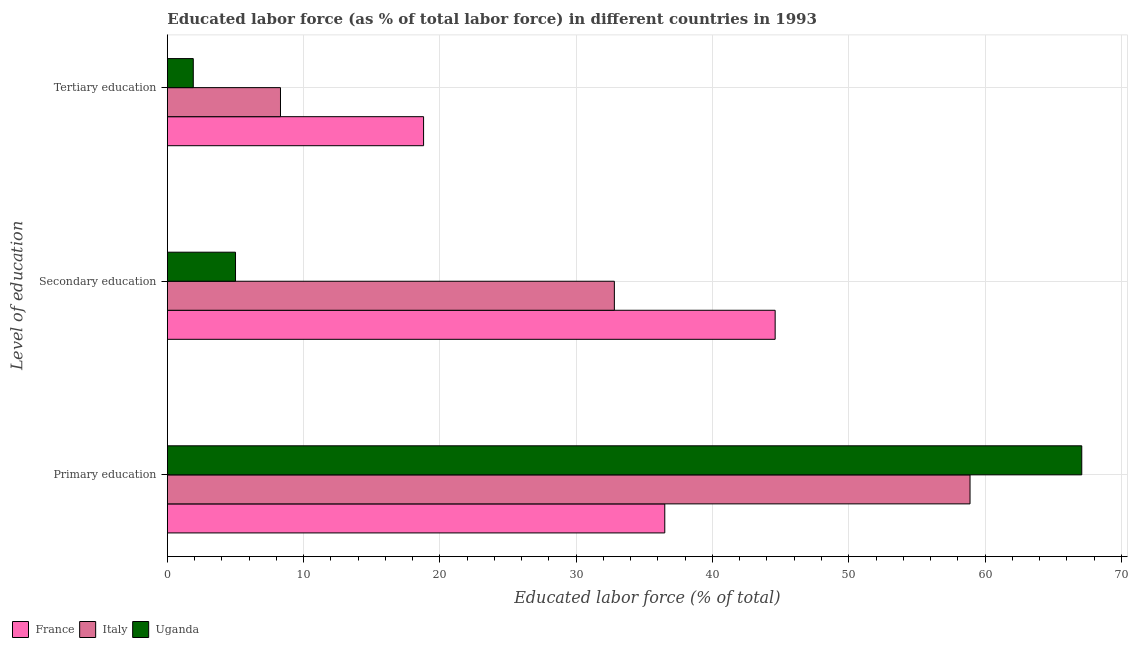How many different coloured bars are there?
Your answer should be very brief. 3. What is the label of the 1st group of bars from the top?
Your response must be concise. Tertiary education. What is the percentage of labor force who received secondary education in France?
Ensure brevity in your answer.  44.6. Across all countries, what is the maximum percentage of labor force who received secondary education?
Your response must be concise. 44.6. Across all countries, what is the minimum percentage of labor force who received primary education?
Your response must be concise. 36.5. In which country was the percentage of labor force who received secondary education maximum?
Make the answer very short. France. In which country was the percentage of labor force who received secondary education minimum?
Give a very brief answer. Uganda. What is the total percentage of labor force who received primary education in the graph?
Offer a terse response. 162.5. What is the difference between the percentage of labor force who received secondary education in Italy and that in Uganda?
Your answer should be compact. 27.8. What is the difference between the percentage of labor force who received secondary education in Italy and the percentage of labor force who received tertiary education in Uganda?
Offer a very short reply. 30.9. What is the average percentage of labor force who received secondary education per country?
Make the answer very short. 27.47. What is the difference between the percentage of labor force who received primary education and percentage of labor force who received secondary education in Italy?
Provide a short and direct response. 26.1. In how many countries, is the percentage of labor force who received secondary education greater than 26 %?
Offer a terse response. 2. What is the ratio of the percentage of labor force who received secondary education in France to that in Uganda?
Provide a succinct answer. 8.92. Is the difference between the percentage of labor force who received tertiary education in Uganda and France greater than the difference between the percentage of labor force who received primary education in Uganda and France?
Provide a short and direct response. No. What is the difference between the highest and the second highest percentage of labor force who received secondary education?
Make the answer very short. 11.8. What is the difference between the highest and the lowest percentage of labor force who received secondary education?
Your answer should be very brief. 39.6. In how many countries, is the percentage of labor force who received secondary education greater than the average percentage of labor force who received secondary education taken over all countries?
Provide a succinct answer. 2. Is the sum of the percentage of labor force who received tertiary education in Uganda and Italy greater than the maximum percentage of labor force who received primary education across all countries?
Make the answer very short. No. What does the 1st bar from the top in Primary education represents?
Ensure brevity in your answer.  Uganda. What does the 3rd bar from the bottom in Secondary education represents?
Offer a very short reply. Uganda. Are all the bars in the graph horizontal?
Give a very brief answer. Yes. How many countries are there in the graph?
Your response must be concise. 3. Are the values on the major ticks of X-axis written in scientific E-notation?
Offer a very short reply. No. What is the title of the graph?
Your response must be concise. Educated labor force (as % of total labor force) in different countries in 1993. What is the label or title of the X-axis?
Provide a succinct answer. Educated labor force (% of total). What is the label or title of the Y-axis?
Your answer should be compact. Level of education. What is the Educated labor force (% of total) in France in Primary education?
Offer a terse response. 36.5. What is the Educated labor force (% of total) of Italy in Primary education?
Provide a succinct answer. 58.9. What is the Educated labor force (% of total) in Uganda in Primary education?
Keep it short and to the point. 67.1. What is the Educated labor force (% of total) in France in Secondary education?
Your answer should be very brief. 44.6. What is the Educated labor force (% of total) of Italy in Secondary education?
Your response must be concise. 32.8. What is the Educated labor force (% of total) of France in Tertiary education?
Your answer should be very brief. 18.8. What is the Educated labor force (% of total) of Italy in Tertiary education?
Make the answer very short. 8.3. What is the Educated labor force (% of total) in Uganda in Tertiary education?
Your answer should be very brief. 1.9. Across all Level of education, what is the maximum Educated labor force (% of total) of France?
Offer a very short reply. 44.6. Across all Level of education, what is the maximum Educated labor force (% of total) in Italy?
Your answer should be very brief. 58.9. Across all Level of education, what is the maximum Educated labor force (% of total) of Uganda?
Offer a very short reply. 67.1. Across all Level of education, what is the minimum Educated labor force (% of total) of France?
Give a very brief answer. 18.8. Across all Level of education, what is the minimum Educated labor force (% of total) of Italy?
Provide a succinct answer. 8.3. Across all Level of education, what is the minimum Educated labor force (% of total) of Uganda?
Offer a very short reply. 1.9. What is the total Educated labor force (% of total) of France in the graph?
Ensure brevity in your answer.  99.9. What is the total Educated labor force (% of total) in Italy in the graph?
Make the answer very short. 100. What is the difference between the Educated labor force (% of total) of Italy in Primary education and that in Secondary education?
Provide a short and direct response. 26.1. What is the difference between the Educated labor force (% of total) of Uganda in Primary education and that in Secondary education?
Your response must be concise. 62.1. What is the difference between the Educated labor force (% of total) of France in Primary education and that in Tertiary education?
Make the answer very short. 17.7. What is the difference between the Educated labor force (% of total) in Italy in Primary education and that in Tertiary education?
Give a very brief answer. 50.6. What is the difference between the Educated labor force (% of total) of Uganda in Primary education and that in Tertiary education?
Keep it short and to the point. 65.2. What is the difference between the Educated labor force (% of total) of France in Secondary education and that in Tertiary education?
Make the answer very short. 25.8. What is the difference between the Educated labor force (% of total) of Uganda in Secondary education and that in Tertiary education?
Make the answer very short. 3.1. What is the difference between the Educated labor force (% of total) in France in Primary education and the Educated labor force (% of total) in Italy in Secondary education?
Offer a very short reply. 3.7. What is the difference between the Educated labor force (% of total) in France in Primary education and the Educated labor force (% of total) in Uganda in Secondary education?
Make the answer very short. 31.5. What is the difference between the Educated labor force (% of total) in Italy in Primary education and the Educated labor force (% of total) in Uganda in Secondary education?
Provide a short and direct response. 53.9. What is the difference between the Educated labor force (% of total) of France in Primary education and the Educated labor force (% of total) of Italy in Tertiary education?
Your answer should be very brief. 28.2. What is the difference between the Educated labor force (% of total) in France in Primary education and the Educated labor force (% of total) in Uganda in Tertiary education?
Provide a succinct answer. 34.6. What is the difference between the Educated labor force (% of total) in Italy in Primary education and the Educated labor force (% of total) in Uganda in Tertiary education?
Offer a terse response. 57. What is the difference between the Educated labor force (% of total) of France in Secondary education and the Educated labor force (% of total) of Italy in Tertiary education?
Keep it short and to the point. 36.3. What is the difference between the Educated labor force (% of total) in France in Secondary education and the Educated labor force (% of total) in Uganda in Tertiary education?
Ensure brevity in your answer.  42.7. What is the difference between the Educated labor force (% of total) in Italy in Secondary education and the Educated labor force (% of total) in Uganda in Tertiary education?
Ensure brevity in your answer.  30.9. What is the average Educated labor force (% of total) in France per Level of education?
Provide a short and direct response. 33.3. What is the average Educated labor force (% of total) of Italy per Level of education?
Make the answer very short. 33.33. What is the average Educated labor force (% of total) of Uganda per Level of education?
Offer a very short reply. 24.67. What is the difference between the Educated labor force (% of total) of France and Educated labor force (% of total) of Italy in Primary education?
Ensure brevity in your answer.  -22.4. What is the difference between the Educated labor force (% of total) in France and Educated labor force (% of total) in Uganda in Primary education?
Offer a terse response. -30.6. What is the difference between the Educated labor force (% of total) in Italy and Educated labor force (% of total) in Uganda in Primary education?
Offer a terse response. -8.2. What is the difference between the Educated labor force (% of total) of France and Educated labor force (% of total) of Uganda in Secondary education?
Provide a short and direct response. 39.6. What is the difference between the Educated labor force (% of total) of Italy and Educated labor force (% of total) of Uganda in Secondary education?
Ensure brevity in your answer.  27.8. What is the difference between the Educated labor force (% of total) of France and Educated labor force (% of total) of Uganda in Tertiary education?
Make the answer very short. 16.9. What is the difference between the Educated labor force (% of total) in Italy and Educated labor force (% of total) in Uganda in Tertiary education?
Ensure brevity in your answer.  6.4. What is the ratio of the Educated labor force (% of total) in France in Primary education to that in Secondary education?
Provide a short and direct response. 0.82. What is the ratio of the Educated labor force (% of total) of Italy in Primary education to that in Secondary education?
Ensure brevity in your answer.  1.8. What is the ratio of the Educated labor force (% of total) in Uganda in Primary education to that in Secondary education?
Provide a short and direct response. 13.42. What is the ratio of the Educated labor force (% of total) in France in Primary education to that in Tertiary education?
Ensure brevity in your answer.  1.94. What is the ratio of the Educated labor force (% of total) of Italy in Primary education to that in Tertiary education?
Provide a short and direct response. 7.1. What is the ratio of the Educated labor force (% of total) of Uganda in Primary education to that in Tertiary education?
Your answer should be very brief. 35.32. What is the ratio of the Educated labor force (% of total) of France in Secondary education to that in Tertiary education?
Your response must be concise. 2.37. What is the ratio of the Educated labor force (% of total) of Italy in Secondary education to that in Tertiary education?
Give a very brief answer. 3.95. What is the ratio of the Educated labor force (% of total) in Uganda in Secondary education to that in Tertiary education?
Your answer should be compact. 2.63. What is the difference between the highest and the second highest Educated labor force (% of total) of France?
Your answer should be very brief. 8.1. What is the difference between the highest and the second highest Educated labor force (% of total) of Italy?
Your response must be concise. 26.1. What is the difference between the highest and the second highest Educated labor force (% of total) in Uganda?
Your answer should be compact. 62.1. What is the difference between the highest and the lowest Educated labor force (% of total) in France?
Offer a very short reply. 25.8. What is the difference between the highest and the lowest Educated labor force (% of total) of Italy?
Your answer should be compact. 50.6. What is the difference between the highest and the lowest Educated labor force (% of total) in Uganda?
Your answer should be compact. 65.2. 